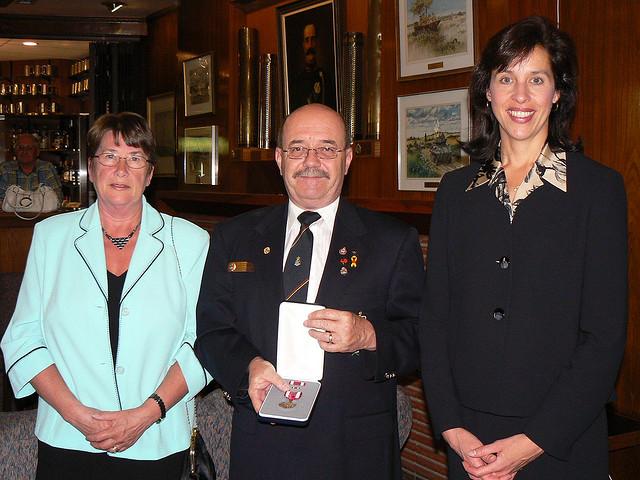Is the woman on the right wearing a solid color blouse?
Concise answer only. No. Is this indoors?
Keep it brief. Yes. How many males are in the scene?
Concise answer only. 1. How many people is in the photo?
Answer briefly. 3. 